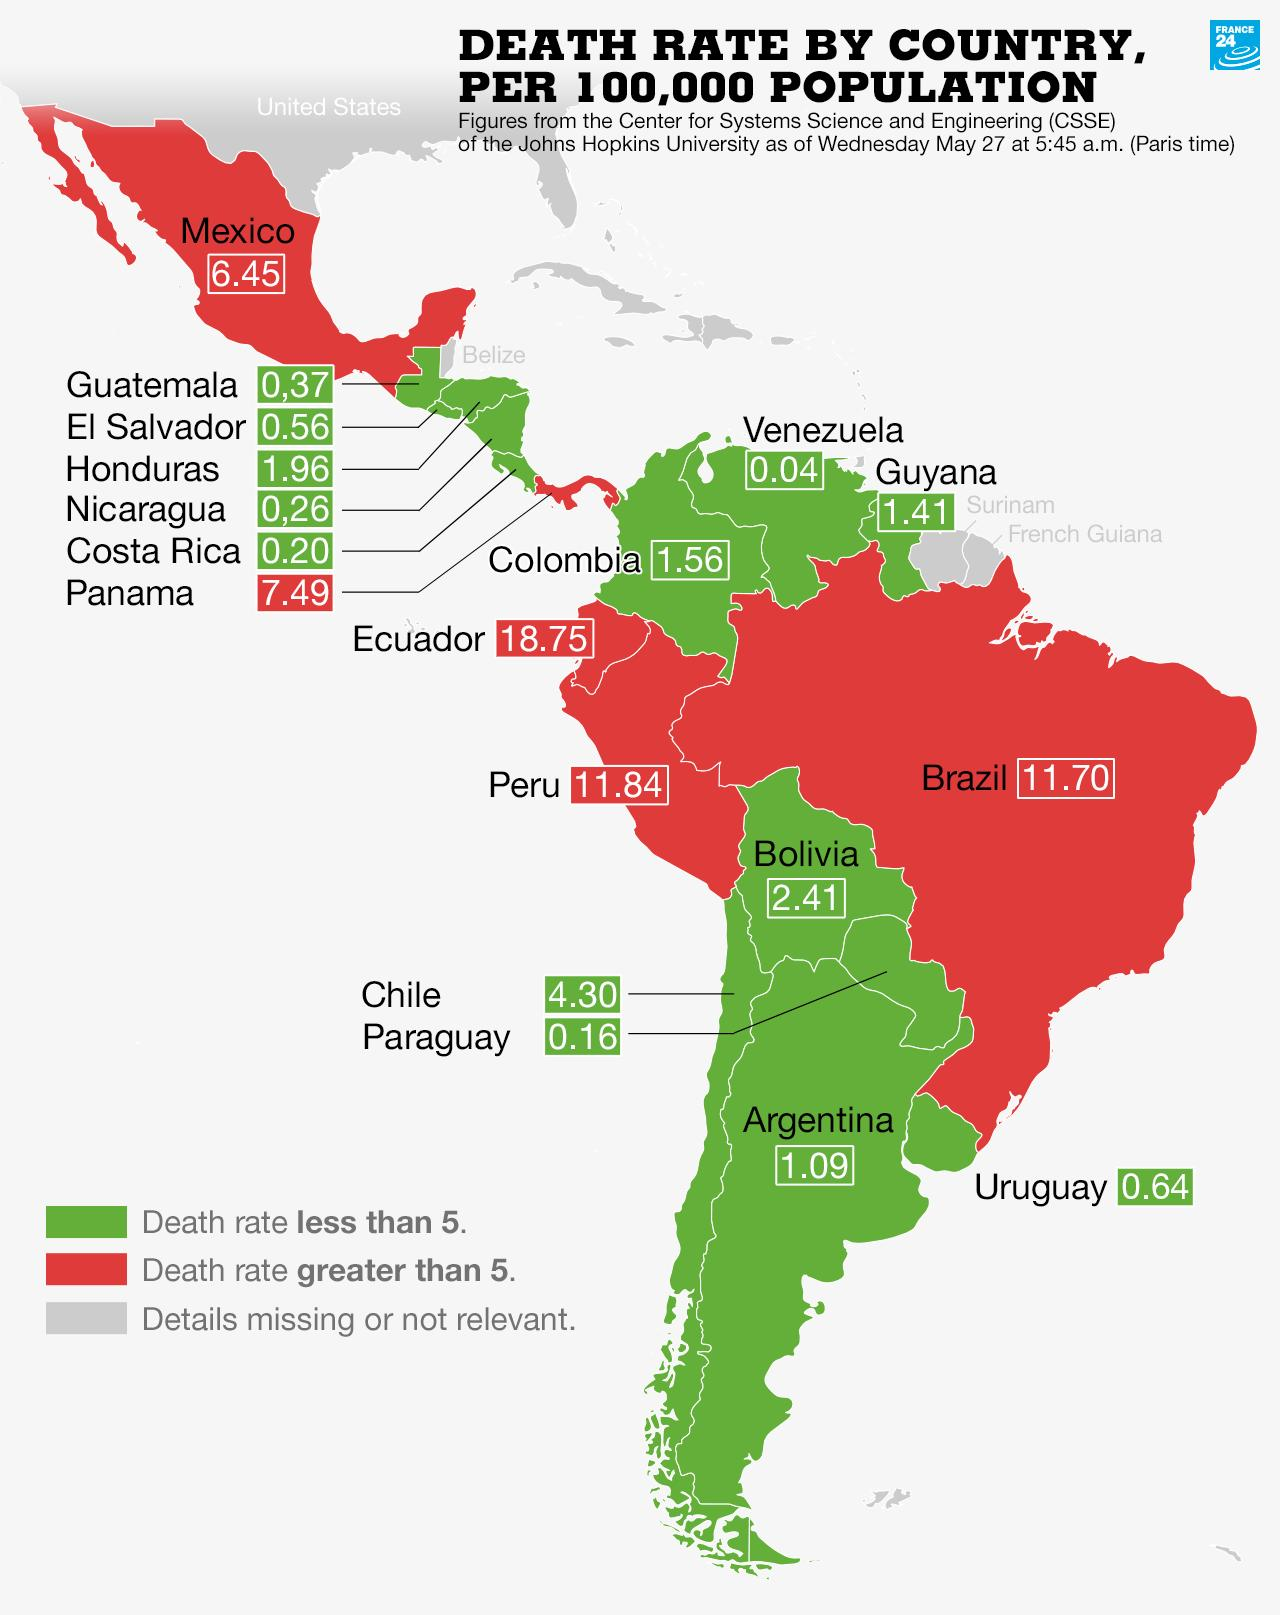Draw attention to some important aspects in this diagram. Venezuela has the lowest recorded death rate among all countries. Countries marked in red denote those with a death rate greater than 5%. We will display countries with a death rate less than 5 as green by coloring them in that hue. Ecuador has the highest death rate among all countries. There are 13 countries with a death rate lower than 5. 